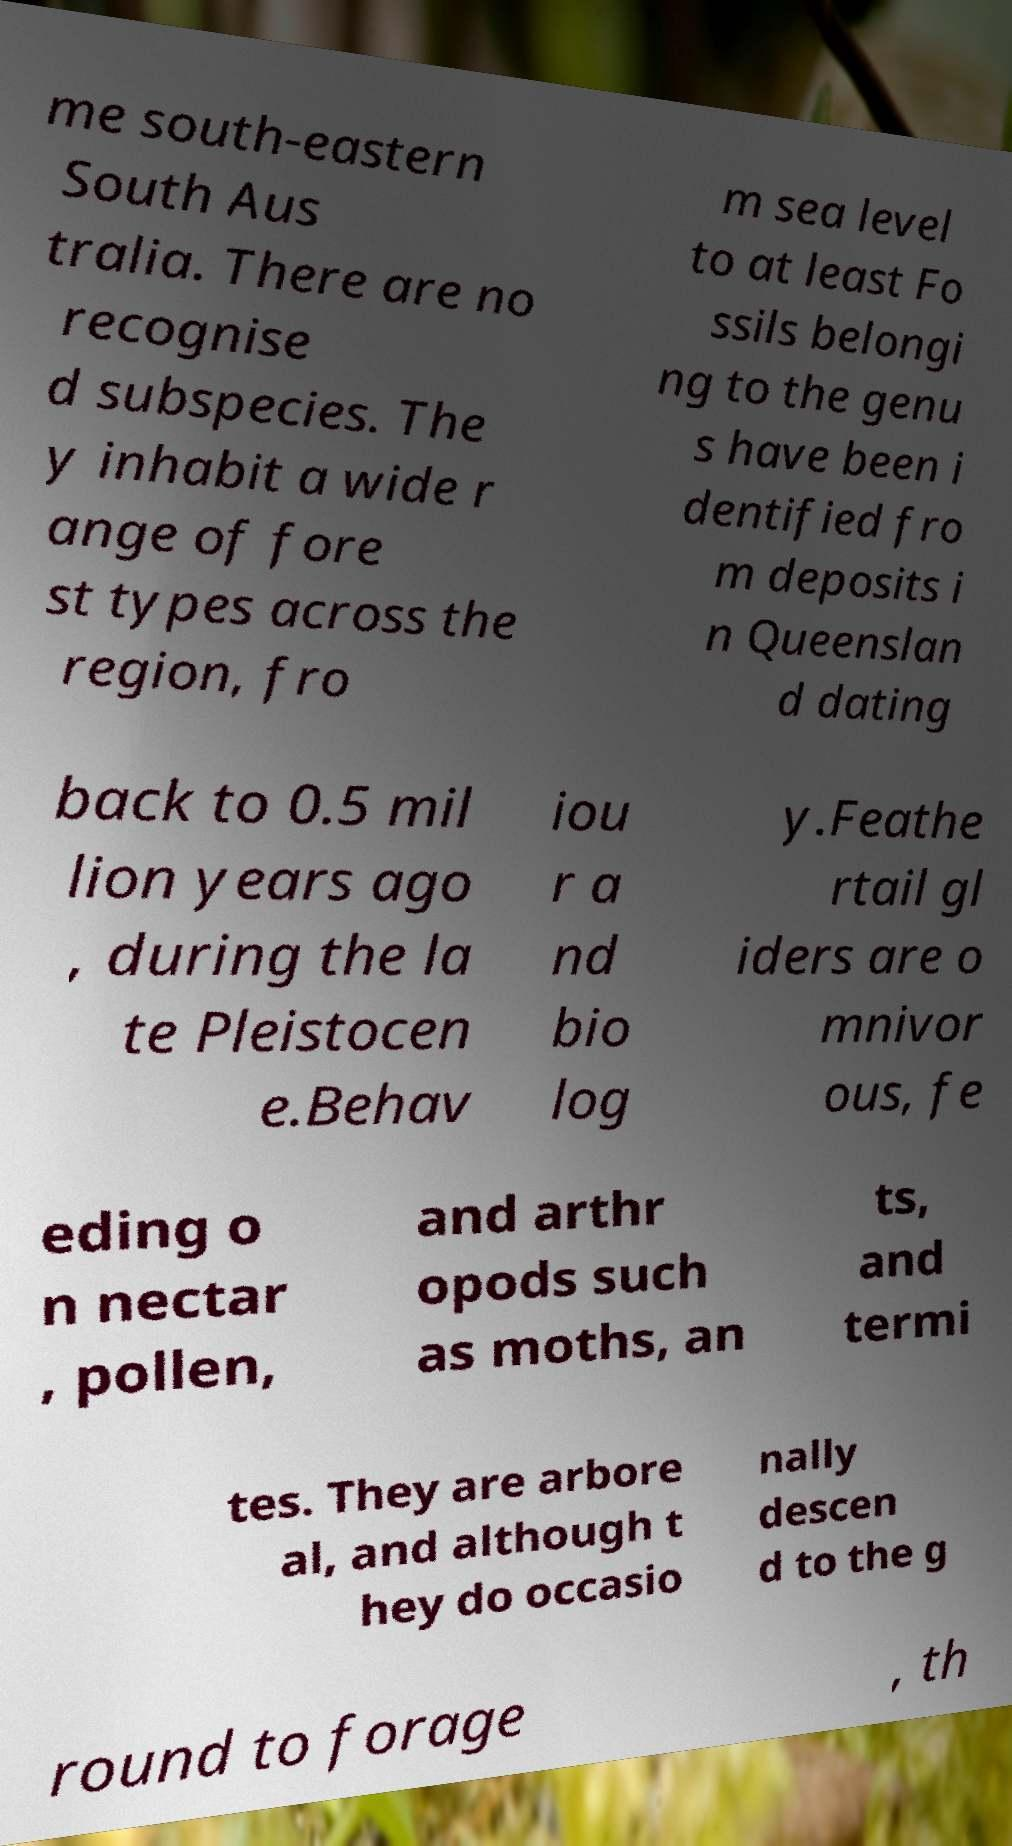Can you accurately transcribe the text from the provided image for me? me south-eastern South Aus tralia. There are no recognise d subspecies. The y inhabit a wide r ange of fore st types across the region, fro m sea level to at least Fo ssils belongi ng to the genu s have been i dentified fro m deposits i n Queenslan d dating back to 0.5 mil lion years ago , during the la te Pleistocen e.Behav iou r a nd bio log y.Feathe rtail gl iders are o mnivor ous, fe eding o n nectar , pollen, and arthr opods such as moths, an ts, and termi tes. They are arbore al, and although t hey do occasio nally descen d to the g round to forage , th 